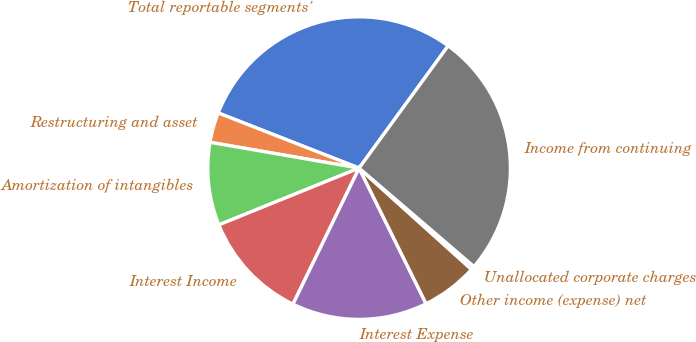Convert chart. <chart><loc_0><loc_0><loc_500><loc_500><pie_chart><fcel>Total reportable segments'<fcel>Restructuring and asset<fcel>Amortization of intangibles<fcel>Interest Income<fcel>Interest Expense<fcel>Other income (expense) net<fcel>Unallocated corporate charges<fcel>Income from continuing<nl><fcel>29.08%<fcel>3.21%<fcel>8.85%<fcel>11.68%<fcel>14.5%<fcel>6.03%<fcel>0.39%<fcel>26.26%<nl></chart> 